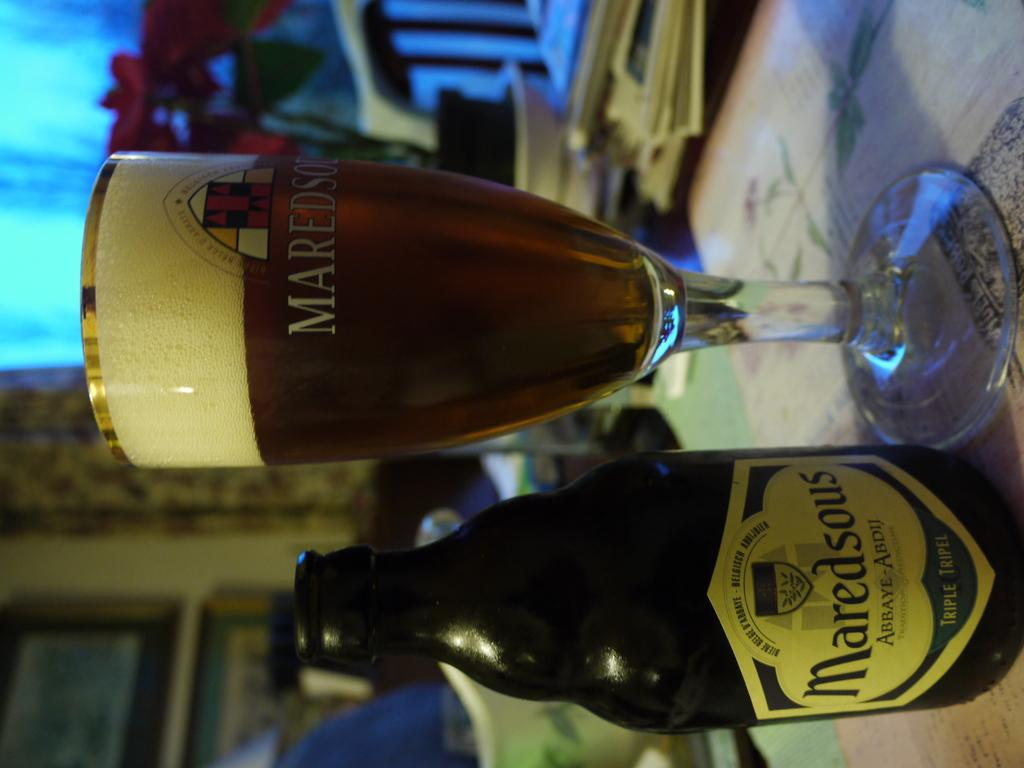<image>
Present a compact description of the photo's key features. A beer bottle and a glass, where the bottle says Maredsous. 